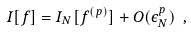Convert formula to latex. <formula><loc_0><loc_0><loc_500><loc_500>I [ f ] = I _ { N } [ f ^ { ( p ) } ] + O ( \epsilon _ { N } ^ { p } ) \ ,</formula> 